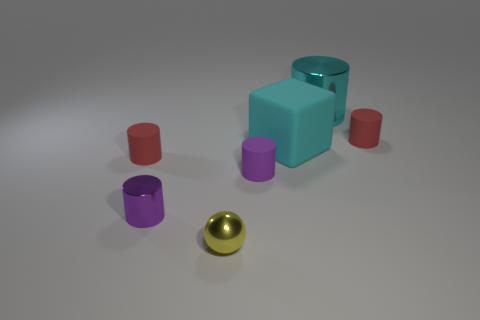Is the material of the small yellow thing the same as the block?
Offer a terse response. No. How many tiny metal things have the same shape as the cyan matte object?
Make the answer very short. 0. What is the shape of the yellow thing that is the same material as the large cylinder?
Offer a very short reply. Sphere. The matte cylinder behind the red matte thing that is left of the cyan metal object is what color?
Make the answer very short. Red. Do the large metallic cylinder and the metal ball have the same color?
Make the answer very short. No. What material is the tiny red object that is to the left of the small red cylinder on the right side of the large cyan cylinder?
Offer a very short reply. Rubber. There is a big cyan thing that is the same shape as the small purple rubber object; what material is it?
Your response must be concise. Metal. Is there a tiny cylinder that is to the right of the red matte thing behind the red object left of the big block?
Offer a terse response. No. How many other things are there of the same color as the big cube?
Your answer should be compact. 1. How many shiny things are both behind the big cyan matte block and in front of the tiny shiny cylinder?
Your answer should be very brief. 0. 